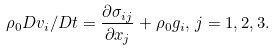<formula> <loc_0><loc_0><loc_500><loc_500>\rho _ { 0 } D v _ { i } / D t = \frac { \partial \sigma _ { i j } } { \partial x _ { j } } + \rho _ { 0 } g _ { i } , \, j = 1 , 2 , 3 .</formula> 